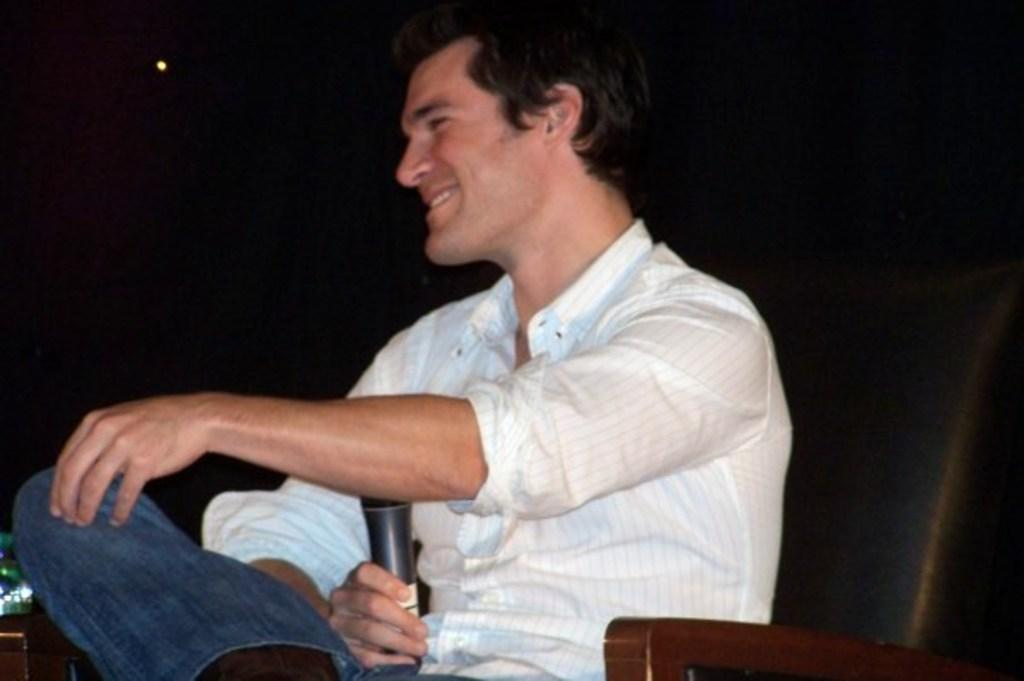Who is present in the image? There is a person in the image. What is the person wearing? The person is wearing a white shirt. What is the person holding in the image? The person is holding a mic. What is the person's position in the image? The person is sitting. Is there a volcano erupting in the background of the image? No, there is no volcano present in the image. What color is the crayon the person is using in the image? There is no crayon present in the image. 